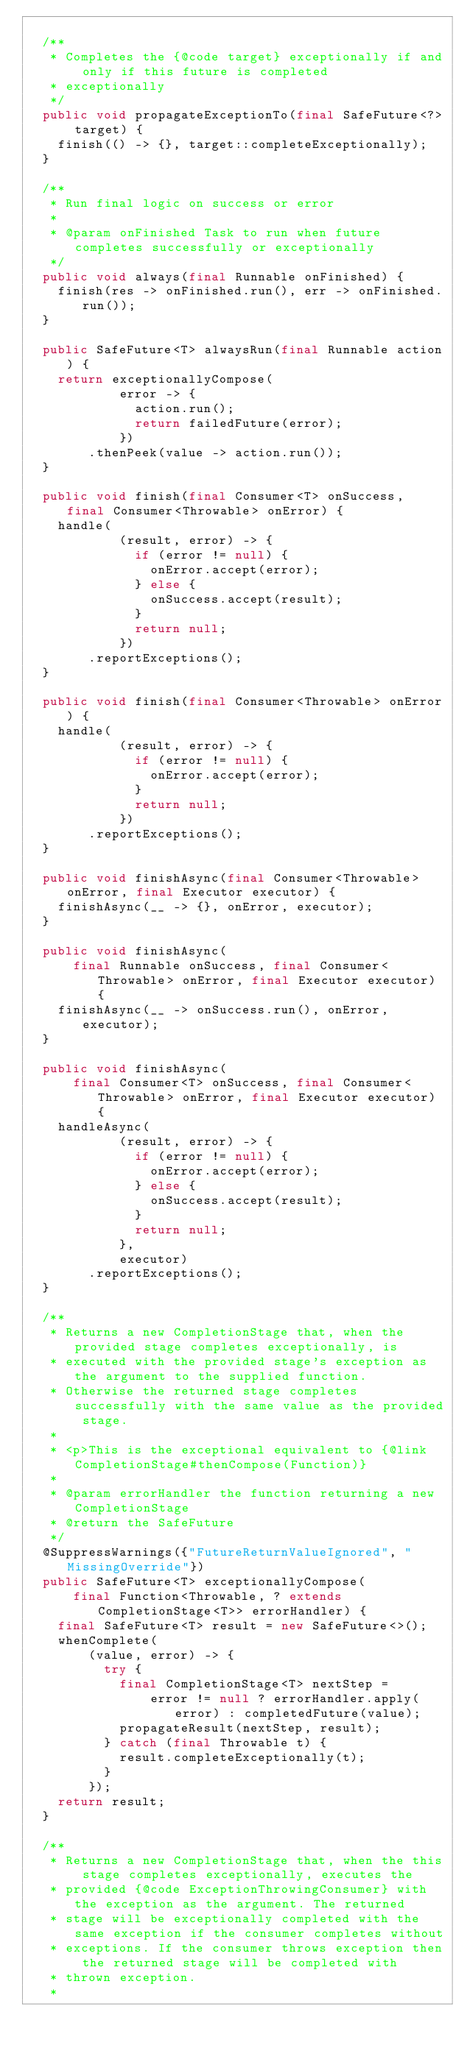Convert code to text. <code><loc_0><loc_0><loc_500><loc_500><_Java_>
  /**
   * Completes the {@code target} exceptionally if and only if this future is completed
   * exceptionally
   */
  public void propagateExceptionTo(final SafeFuture<?> target) {
    finish(() -> {}, target::completeExceptionally);
  }

  /**
   * Run final logic on success or error
   *
   * @param onFinished Task to run when future completes successfully or exceptionally
   */
  public void always(final Runnable onFinished) {
    finish(res -> onFinished.run(), err -> onFinished.run());
  }

  public SafeFuture<T> alwaysRun(final Runnable action) {
    return exceptionallyCompose(
            error -> {
              action.run();
              return failedFuture(error);
            })
        .thenPeek(value -> action.run());
  }

  public void finish(final Consumer<T> onSuccess, final Consumer<Throwable> onError) {
    handle(
            (result, error) -> {
              if (error != null) {
                onError.accept(error);
              } else {
                onSuccess.accept(result);
              }
              return null;
            })
        .reportExceptions();
  }

  public void finish(final Consumer<Throwable> onError) {
    handle(
            (result, error) -> {
              if (error != null) {
                onError.accept(error);
              }
              return null;
            })
        .reportExceptions();
  }

  public void finishAsync(final Consumer<Throwable> onError, final Executor executor) {
    finishAsync(__ -> {}, onError, executor);
  }

  public void finishAsync(
      final Runnable onSuccess, final Consumer<Throwable> onError, final Executor executor) {
    finishAsync(__ -> onSuccess.run(), onError, executor);
  }

  public void finishAsync(
      final Consumer<T> onSuccess, final Consumer<Throwable> onError, final Executor executor) {
    handleAsync(
            (result, error) -> {
              if (error != null) {
                onError.accept(error);
              } else {
                onSuccess.accept(result);
              }
              return null;
            },
            executor)
        .reportExceptions();
  }

  /**
   * Returns a new CompletionStage that, when the provided stage completes exceptionally, is
   * executed with the provided stage's exception as the argument to the supplied function.
   * Otherwise the returned stage completes successfully with the same value as the provided stage.
   *
   * <p>This is the exceptional equivalent to {@link CompletionStage#thenCompose(Function)}
   *
   * @param errorHandler the function returning a new CompletionStage
   * @return the SafeFuture
   */
  @SuppressWarnings({"FutureReturnValueIgnored", "MissingOverride"})
  public SafeFuture<T> exceptionallyCompose(
      final Function<Throwable, ? extends CompletionStage<T>> errorHandler) {
    final SafeFuture<T> result = new SafeFuture<>();
    whenComplete(
        (value, error) -> {
          try {
            final CompletionStage<T> nextStep =
                error != null ? errorHandler.apply(error) : completedFuture(value);
            propagateResult(nextStep, result);
          } catch (final Throwable t) {
            result.completeExceptionally(t);
          }
        });
    return result;
  }

  /**
   * Returns a new CompletionStage that, when the this stage completes exceptionally, executes the
   * provided {@code ExceptionThrowingConsumer} with the exception as the argument. The returned
   * stage will be exceptionally completed with the same exception if the consumer completes without
   * exceptions. If the consumer throws exception then the returned stage will be completed with
   * thrown exception.
   *</code> 